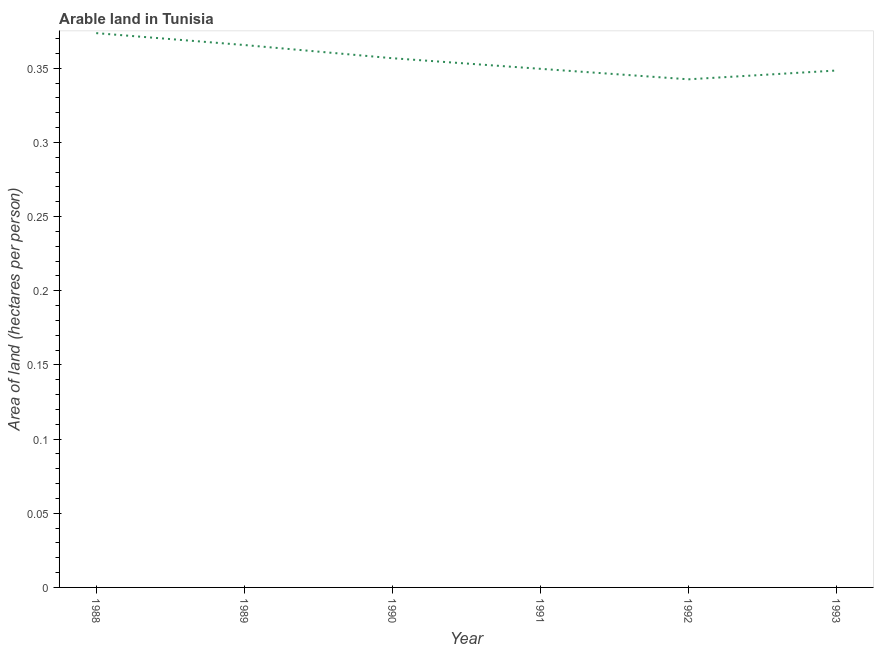What is the area of arable land in 1993?
Make the answer very short. 0.35. Across all years, what is the maximum area of arable land?
Make the answer very short. 0.37. Across all years, what is the minimum area of arable land?
Provide a short and direct response. 0.34. In which year was the area of arable land maximum?
Make the answer very short. 1988. In which year was the area of arable land minimum?
Give a very brief answer. 1992. What is the sum of the area of arable land?
Your response must be concise. 2.14. What is the difference between the area of arable land in 1989 and 1993?
Provide a succinct answer. 0.02. What is the average area of arable land per year?
Your answer should be very brief. 0.36. What is the median area of arable land?
Offer a terse response. 0.35. In how many years, is the area of arable land greater than 0.21000000000000002 hectares per person?
Your response must be concise. 6. What is the ratio of the area of arable land in 1990 to that in 1991?
Your answer should be very brief. 1.02. Is the difference between the area of arable land in 1988 and 1990 greater than the difference between any two years?
Offer a very short reply. No. What is the difference between the highest and the second highest area of arable land?
Ensure brevity in your answer.  0.01. Is the sum of the area of arable land in 1992 and 1993 greater than the maximum area of arable land across all years?
Provide a succinct answer. Yes. What is the difference between the highest and the lowest area of arable land?
Your answer should be very brief. 0.03. Are the values on the major ticks of Y-axis written in scientific E-notation?
Keep it short and to the point. No. What is the title of the graph?
Your response must be concise. Arable land in Tunisia. What is the label or title of the X-axis?
Your response must be concise. Year. What is the label or title of the Y-axis?
Provide a succinct answer. Area of land (hectares per person). What is the Area of land (hectares per person) of 1988?
Your answer should be compact. 0.37. What is the Area of land (hectares per person) in 1989?
Keep it short and to the point. 0.37. What is the Area of land (hectares per person) in 1990?
Ensure brevity in your answer.  0.36. What is the Area of land (hectares per person) in 1991?
Your answer should be compact. 0.35. What is the Area of land (hectares per person) of 1992?
Make the answer very short. 0.34. What is the Area of land (hectares per person) of 1993?
Give a very brief answer. 0.35. What is the difference between the Area of land (hectares per person) in 1988 and 1989?
Make the answer very short. 0.01. What is the difference between the Area of land (hectares per person) in 1988 and 1990?
Offer a very short reply. 0.02. What is the difference between the Area of land (hectares per person) in 1988 and 1991?
Provide a succinct answer. 0.02. What is the difference between the Area of land (hectares per person) in 1988 and 1992?
Provide a succinct answer. 0.03. What is the difference between the Area of land (hectares per person) in 1988 and 1993?
Your answer should be compact. 0.03. What is the difference between the Area of land (hectares per person) in 1989 and 1990?
Make the answer very short. 0.01. What is the difference between the Area of land (hectares per person) in 1989 and 1991?
Make the answer very short. 0.02. What is the difference between the Area of land (hectares per person) in 1989 and 1992?
Give a very brief answer. 0.02. What is the difference between the Area of land (hectares per person) in 1989 and 1993?
Ensure brevity in your answer.  0.02. What is the difference between the Area of land (hectares per person) in 1990 and 1991?
Your answer should be compact. 0.01. What is the difference between the Area of land (hectares per person) in 1990 and 1992?
Provide a short and direct response. 0.01. What is the difference between the Area of land (hectares per person) in 1990 and 1993?
Provide a short and direct response. 0.01. What is the difference between the Area of land (hectares per person) in 1991 and 1992?
Ensure brevity in your answer.  0.01. What is the difference between the Area of land (hectares per person) in 1991 and 1993?
Provide a short and direct response. 0. What is the difference between the Area of land (hectares per person) in 1992 and 1993?
Keep it short and to the point. -0.01. What is the ratio of the Area of land (hectares per person) in 1988 to that in 1990?
Keep it short and to the point. 1.05. What is the ratio of the Area of land (hectares per person) in 1988 to that in 1991?
Ensure brevity in your answer.  1.07. What is the ratio of the Area of land (hectares per person) in 1988 to that in 1992?
Provide a short and direct response. 1.09. What is the ratio of the Area of land (hectares per person) in 1988 to that in 1993?
Provide a short and direct response. 1.07. What is the ratio of the Area of land (hectares per person) in 1989 to that in 1990?
Keep it short and to the point. 1.02. What is the ratio of the Area of land (hectares per person) in 1989 to that in 1991?
Offer a terse response. 1.05. What is the ratio of the Area of land (hectares per person) in 1989 to that in 1992?
Your response must be concise. 1.07. What is the ratio of the Area of land (hectares per person) in 1989 to that in 1993?
Offer a very short reply. 1.05. What is the ratio of the Area of land (hectares per person) in 1990 to that in 1992?
Ensure brevity in your answer.  1.04. What is the ratio of the Area of land (hectares per person) in 1992 to that in 1993?
Make the answer very short. 0.98. 